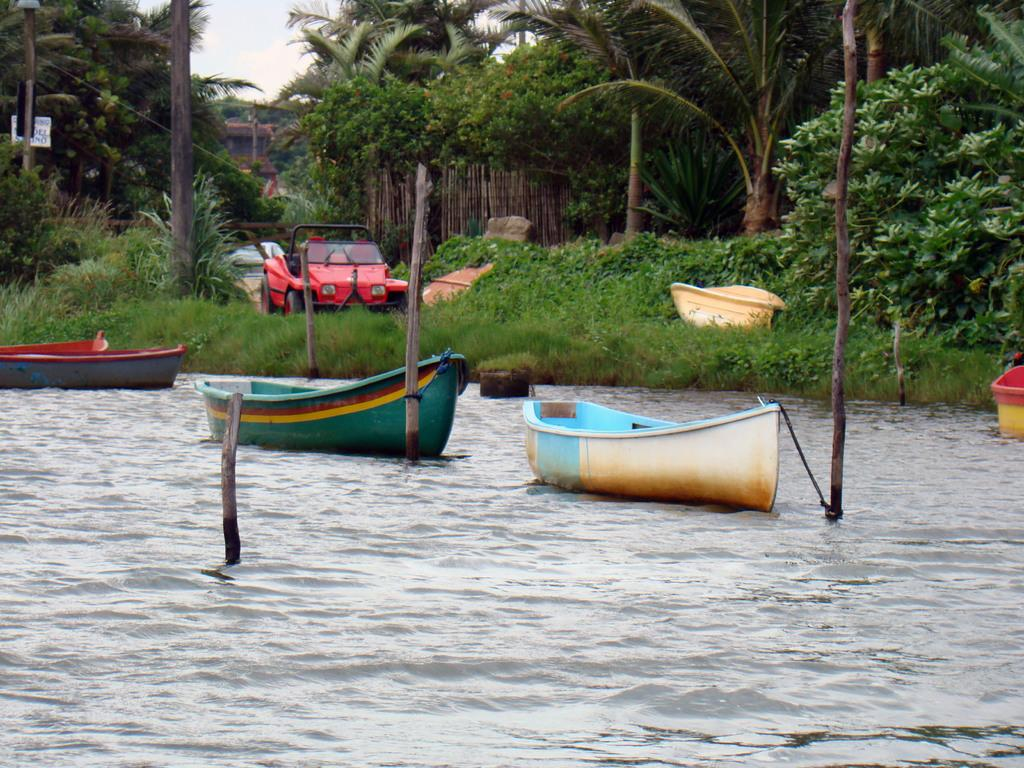What is on the water in the image? There are boats on the water in the image. What else can be seen in the water besides the boats? There are sticks in the water. What type of vehicles are present in the image? Motor vehicles are present in the image. What type of vegetation is visible in the image? Shrubs, bushes, and trees are visible in the image. What type of barrier is present in the image? There is a wooden fence in the image. What part of the natural environment is visible in the image? The sky is visible in the image. How many houses are visible in the image? There are no houses present in the image. What type of addition can be seen on the boats in the image? There are no additions visible on the boats in the image. 